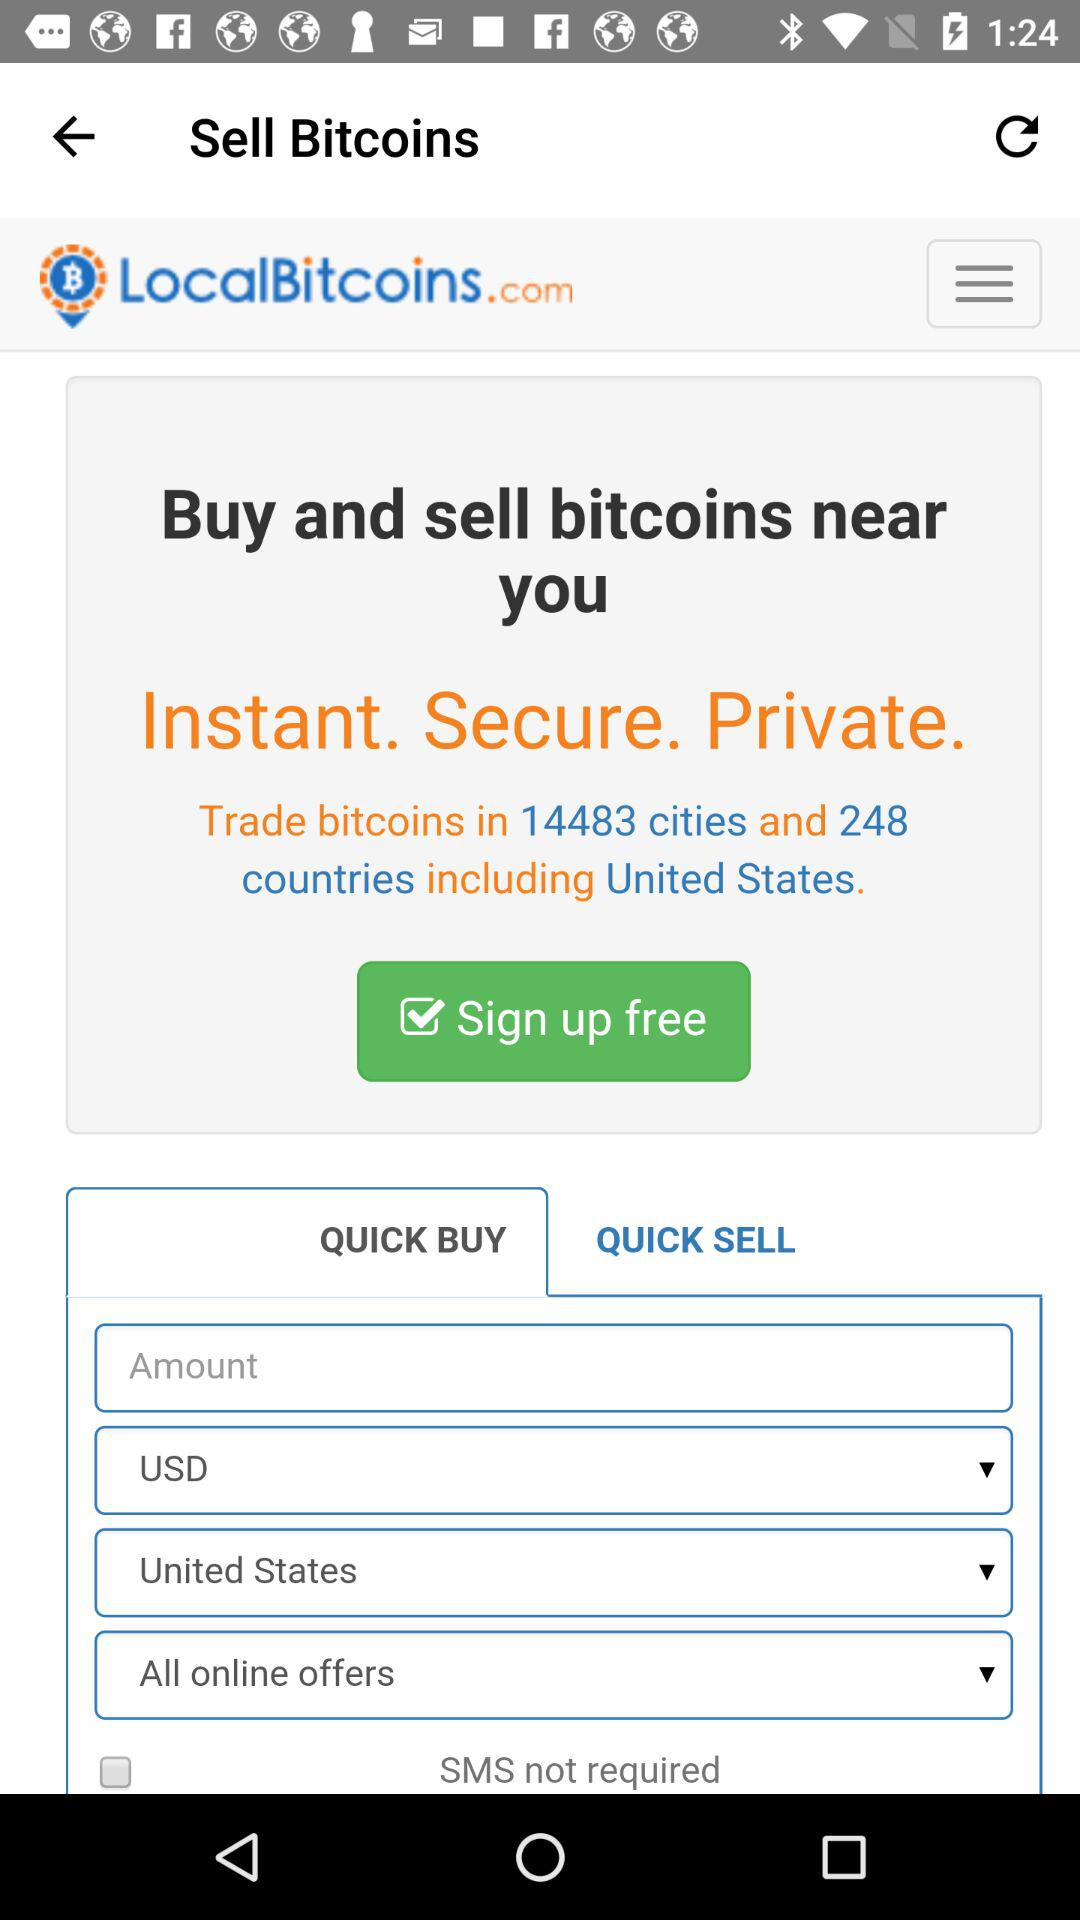In how many cities can bitcoins be traded? Bitcoins can be traded in 14483 cities. 